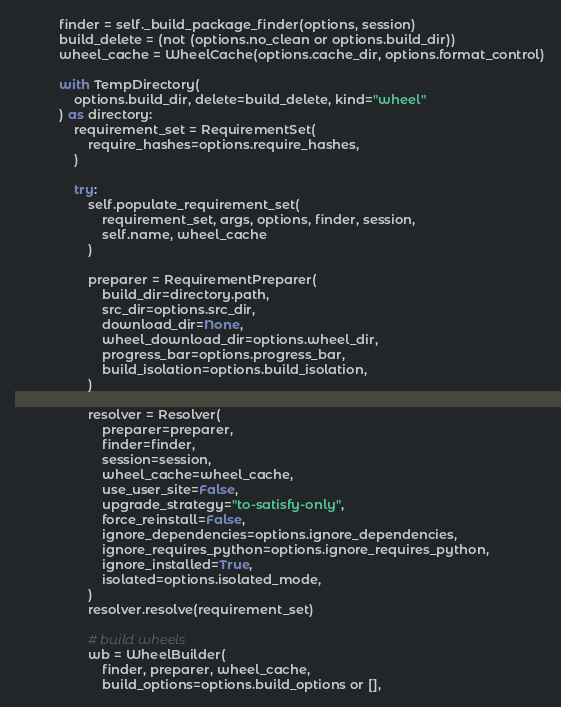<code> <loc_0><loc_0><loc_500><loc_500><_Python_>            finder = self._build_package_finder(options, session)
            build_delete = (not (options.no_clean or options.build_dir))
            wheel_cache = WheelCache(options.cache_dir, options.format_control)

            with TempDirectory(
                options.build_dir, delete=build_delete, kind="wheel"
            ) as directory:
                requirement_set = RequirementSet(
                    require_hashes=options.require_hashes,
                )

                try:
                    self.populate_requirement_set(
                        requirement_set, args, options, finder, session,
                        self.name, wheel_cache
                    )

                    preparer = RequirementPreparer(
                        build_dir=directory.path,
                        src_dir=options.src_dir,
                        download_dir=None,
                        wheel_download_dir=options.wheel_dir,
                        progress_bar=options.progress_bar,
                        build_isolation=options.build_isolation,
                    )

                    resolver = Resolver(
                        preparer=preparer,
                        finder=finder,
                        session=session,
                        wheel_cache=wheel_cache,
                        use_user_site=False,
                        upgrade_strategy="to-satisfy-only",
                        force_reinstall=False,
                        ignore_dependencies=options.ignore_dependencies,
                        ignore_requires_python=options.ignore_requires_python,
                        ignore_installed=True,
                        isolated=options.isolated_mode,
                    )
                    resolver.resolve(requirement_set)

                    # build wheels
                    wb = WheelBuilder(
                        finder, preparer, wheel_cache,
                        build_options=options.build_options or [],</code> 